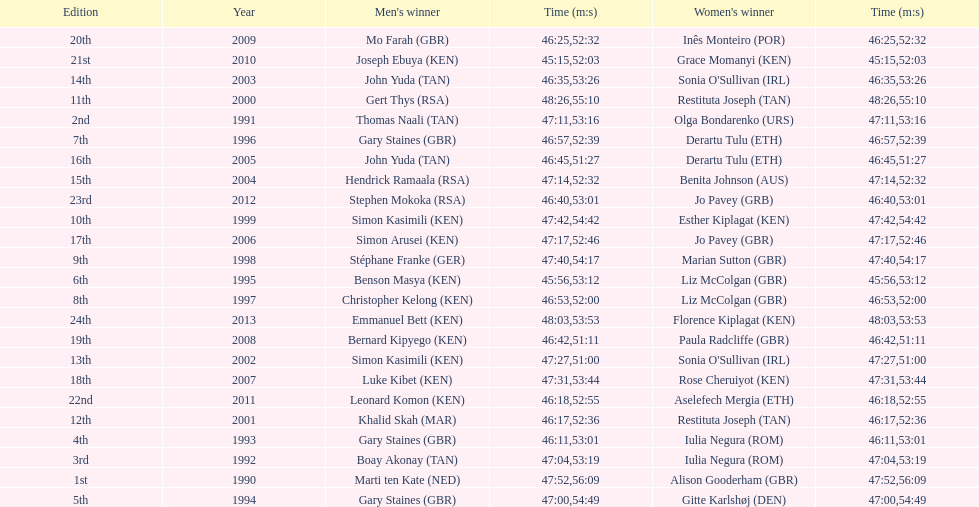How much time did sonia o'sullivan require to finish in 2003? 53:26. 